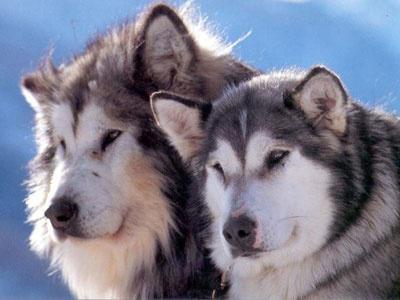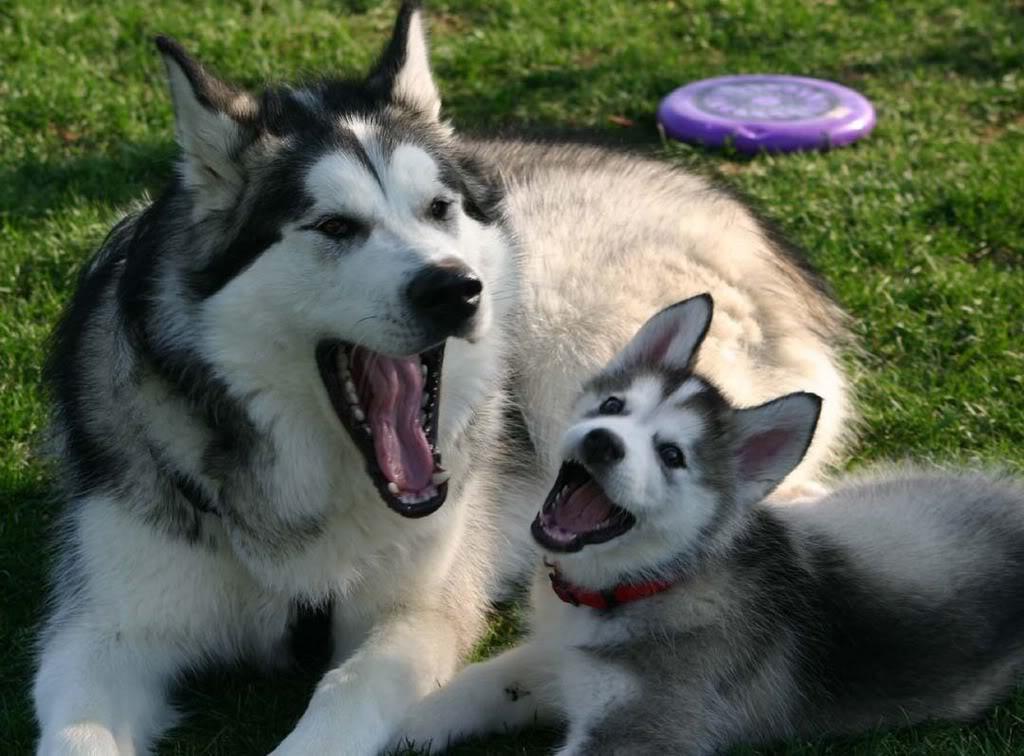The first image is the image on the left, the second image is the image on the right. Given the left and right images, does the statement "The left image contains exactly two husky dogs of similar size and age posed with bodies turned leftward, mouths closed, and gazes matched." hold true? Answer yes or no. Yes. The first image is the image on the left, the second image is the image on the right. For the images shown, is this caption "The right image contains exactly one dog." true? Answer yes or no. No. 